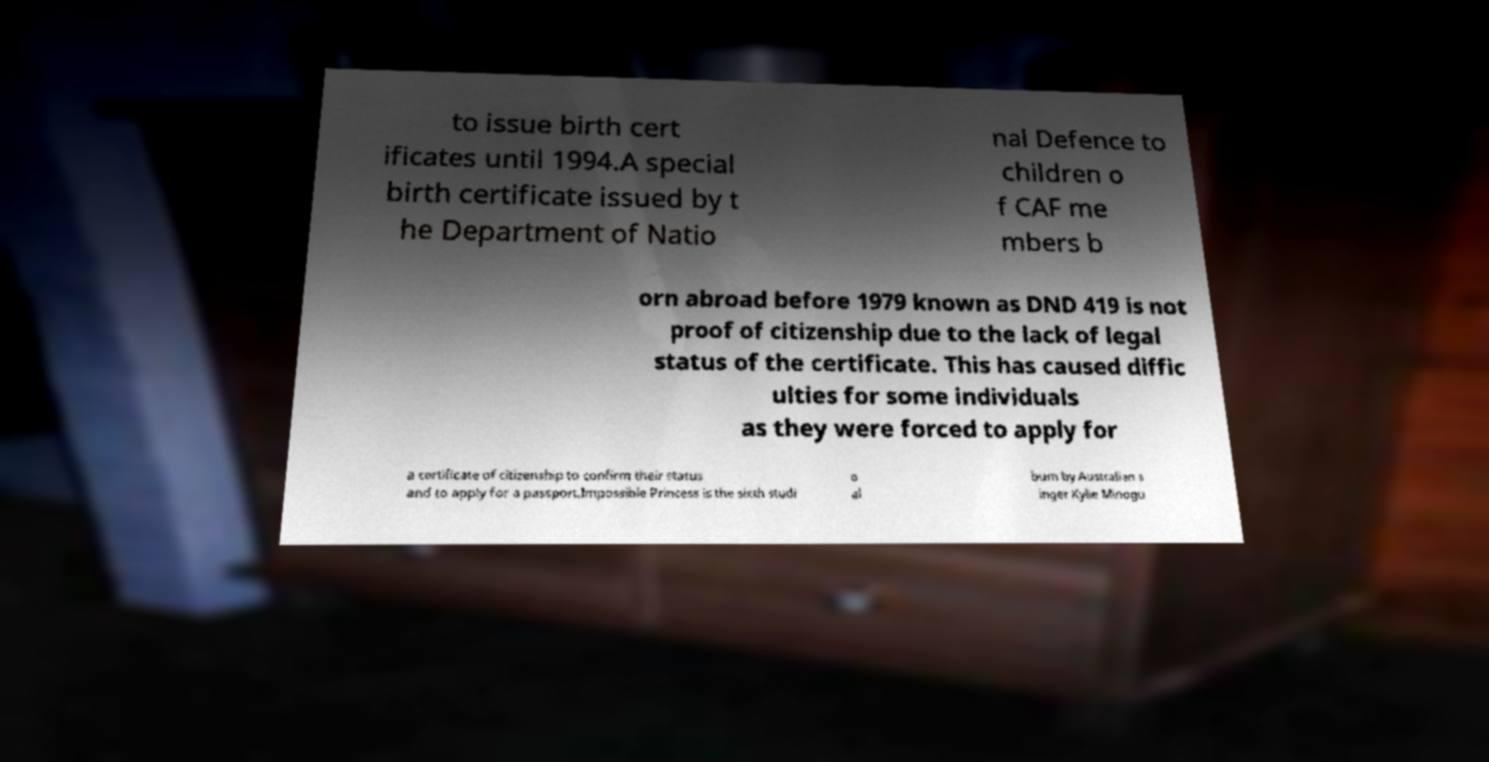Please identify and transcribe the text found in this image. to issue birth cert ificates until 1994.A special birth certificate issued by t he Department of Natio nal Defence to children o f CAF me mbers b orn abroad before 1979 known as DND 419 is not proof of citizenship due to the lack of legal status of the certificate. This has caused diffic ulties for some individuals as they were forced to apply for a certificate of citizenship to confirm their status and to apply for a passport.Impossible Princess is the sixth studi o al bum by Australian s inger Kylie Minogu 